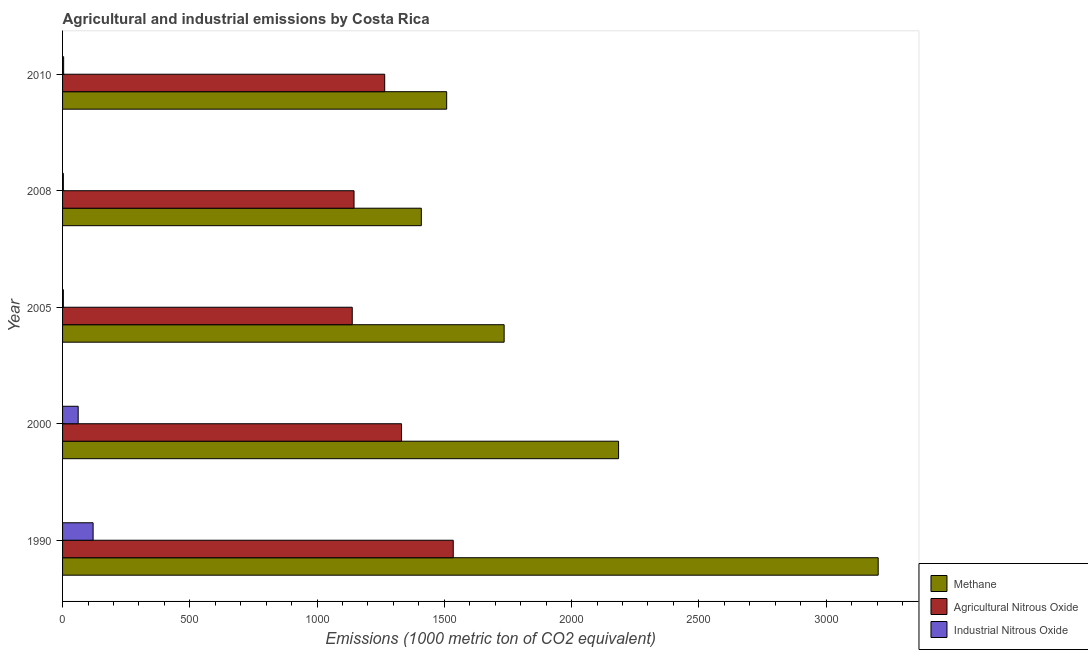How many groups of bars are there?
Give a very brief answer. 5. Are the number of bars per tick equal to the number of legend labels?
Provide a short and direct response. Yes. Are the number of bars on each tick of the Y-axis equal?
Ensure brevity in your answer.  Yes. How many bars are there on the 4th tick from the top?
Your answer should be very brief. 3. What is the amount of agricultural nitrous oxide emissions in 2008?
Your response must be concise. 1145.2. Across all years, what is the maximum amount of methane emissions?
Your answer should be very brief. 3204.6. In which year was the amount of agricultural nitrous oxide emissions maximum?
Keep it short and to the point. 1990. What is the total amount of agricultural nitrous oxide emissions in the graph?
Provide a succinct answer. 6415.9. What is the difference between the amount of methane emissions in 2005 and that in 2008?
Offer a very short reply. 325.4. What is the difference between the amount of industrial nitrous oxide emissions in 2000 and the amount of methane emissions in 2008?
Your answer should be compact. -1348.2. What is the average amount of industrial nitrous oxide emissions per year?
Provide a succinct answer. 38.36. In the year 2010, what is the difference between the amount of industrial nitrous oxide emissions and amount of methane emissions?
Your answer should be compact. -1505. In how many years, is the amount of industrial nitrous oxide emissions greater than 1400 metric ton?
Ensure brevity in your answer.  0. What is the ratio of the amount of industrial nitrous oxide emissions in 2005 to that in 2008?
Offer a very short reply. 1. Is the amount of agricultural nitrous oxide emissions in 2000 less than that in 2005?
Provide a succinct answer. No. Is the difference between the amount of industrial nitrous oxide emissions in 1990 and 2005 greater than the difference between the amount of methane emissions in 1990 and 2005?
Provide a short and direct response. No. What is the difference between the highest and the second highest amount of industrial nitrous oxide emissions?
Keep it short and to the point. 58.6. What is the difference between the highest and the lowest amount of industrial nitrous oxide emissions?
Offer a terse response. 116.9. In how many years, is the amount of industrial nitrous oxide emissions greater than the average amount of industrial nitrous oxide emissions taken over all years?
Give a very brief answer. 2. What does the 2nd bar from the top in 1990 represents?
Offer a very short reply. Agricultural Nitrous Oxide. What does the 2nd bar from the bottom in 2008 represents?
Make the answer very short. Agricultural Nitrous Oxide. How many bars are there?
Keep it short and to the point. 15. Are all the bars in the graph horizontal?
Provide a succinct answer. Yes. How many years are there in the graph?
Give a very brief answer. 5. What is the difference between two consecutive major ticks on the X-axis?
Give a very brief answer. 500. Are the values on the major ticks of X-axis written in scientific E-notation?
Provide a short and direct response. No. Does the graph contain any zero values?
Offer a terse response. No. Does the graph contain grids?
Give a very brief answer. No. Where does the legend appear in the graph?
Keep it short and to the point. Bottom right. How are the legend labels stacked?
Ensure brevity in your answer.  Vertical. What is the title of the graph?
Provide a short and direct response. Agricultural and industrial emissions by Costa Rica. Does "Ages 20-60" appear as one of the legend labels in the graph?
Provide a succinct answer. No. What is the label or title of the X-axis?
Your response must be concise. Emissions (1000 metric ton of CO2 equivalent). What is the label or title of the Y-axis?
Make the answer very short. Year. What is the Emissions (1000 metric ton of CO2 equivalent) of Methane in 1990?
Offer a terse response. 3204.6. What is the Emissions (1000 metric ton of CO2 equivalent) in Agricultural Nitrous Oxide in 1990?
Your response must be concise. 1535. What is the Emissions (1000 metric ton of CO2 equivalent) in Industrial Nitrous Oxide in 1990?
Make the answer very short. 120. What is the Emissions (1000 metric ton of CO2 equivalent) in Methane in 2000?
Offer a very short reply. 2184.6. What is the Emissions (1000 metric ton of CO2 equivalent) of Agricultural Nitrous Oxide in 2000?
Give a very brief answer. 1331.8. What is the Emissions (1000 metric ton of CO2 equivalent) of Industrial Nitrous Oxide in 2000?
Make the answer very short. 61.4. What is the Emissions (1000 metric ton of CO2 equivalent) of Methane in 2005?
Provide a succinct answer. 1735. What is the Emissions (1000 metric ton of CO2 equivalent) in Agricultural Nitrous Oxide in 2005?
Provide a short and direct response. 1138.2. What is the Emissions (1000 metric ton of CO2 equivalent) of Industrial Nitrous Oxide in 2005?
Keep it short and to the point. 3.1. What is the Emissions (1000 metric ton of CO2 equivalent) of Methane in 2008?
Ensure brevity in your answer.  1409.6. What is the Emissions (1000 metric ton of CO2 equivalent) in Agricultural Nitrous Oxide in 2008?
Provide a succinct answer. 1145.2. What is the Emissions (1000 metric ton of CO2 equivalent) of Industrial Nitrous Oxide in 2008?
Provide a succinct answer. 3.1. What is the Emissions (1000 metric ton of CO2 equivalent) of Methane in 2010?
Keep it short and to the point. 1509.2. What is the Emissions (1000 metric ton of CO2 equivalent) of Agricultural Nitrous Oxide in 2010?
Provide a succinct answer. 1265.7. Across all years, what is the maximum Emissions (1000 metric ton of CO2 equivalent) in Methane?
Ensure brevity in your answer.  3204.6. Across all years, what is the maximum Emissions (1000 metric ton of CO2 equivalent) in Agricultural Nitrous Oxide?
Give a very brief answer. 1535. Across all years, what is the maximum Emissions (1000 metric ton of CO2 equivalent) of Industrial Nitrous Oxide?
Provide a succinct answer. 120. Across all years, what is the minimum Emissions (1000 metric ton of CO2 equivalent) of Methane?
Ensure brevity in your answer.  1409.6. Across all years, what is the minimum Emissions (1000 metric ton of CO2 equivalent) of Agricultural Nitrous Oxide?
Offer a very short reply. 1138.2. Across all years, what is the minimum Emissions (1000 metric ton of CO2 equivalent) of Industrial Nitrous Oxide?
Offer a very short reply. 3.1. What is the total Emissions (1000 metric ton of CO2 equivalent) of Methane in the graph?
Make the answer very short. 1.00e+04. What is the total Emissions (1000 metric ton of CO2 equivalent) in Agricultural Nitrous Oxide in the graph?
Your answer should be very brief. 6415.9. What is the total Emissions (1000 metric ton of CO2 equivalent) in Industrial Nitrous Oxide in the graph?
Your response must be concise. 191.8. What is the difference between the Emissions (1000 metric ton of CO2 equivalent) in Methane in 1990 and that in 2000?
Offer a very short reply. 1020. What is the difference between the Emissions (1000 metric ton of CO2 equivalent) of Agricultural Nitrous Oxide in 1990 and that in 2000?
Your answer should be compact. 203.2. What is the difference between the Emissions (1000 metric ton of CO2 equivalent) of Industrial Nitrous Oxide in 1990 and that in 2000?
Your answer should be very brief. 58.6. What is the difference between the Emissions (1000 metric ton of CO2 equivalent) of Methane in 1990 and that in 2005?
Provide a succinct answer. 1469.6. What is the difference between the Emissions (1000 metric ton of CO2 equivalent) of Agricultural Nitrous Oxide in 1990 and that in 2005?
Your response must be concise. 396.8. What is the difference between the Emissions (1000 metric ton of CO2 equivalent) of Industrial Nitrous Oxide in 1990 and that in 2005?
Offer a very short reply. 116.9. What is the difference between the Emissions (1000 metric ton of CO2 equivalent) in Methane in 1990 and that in 2008?
Your answer should be compact. 1795. What is the difference between the Emissions (1000 metric ton of CO2 equivalent) in Agricultural Nitrous Oxide in 1990 and that in 2008?
Provide a short and direct response. 389.8. What is the difference between the Emissions (1000 metric ton of CO2 equivalent) in Industrial Nitrous Oxide in 1990 and that in 2008?
Provide a short and direct response. 116.9. What is the difference between the Emissions (1000 metric ton of CO2 equivalent) in Methane in 1990 and that in 2010?
Make the answer very short. 1695.4. What is the difference between the Emissions (1000 metric ton of CO2 equivalent) of Agricultural Nitrous Oxide in 1990 and that in 2010?
Ensure brevity in your answer.  269.3. What is the difference between the Emissions (1000 metric ton of CO2 equivalent) in Industrial Nitrous Oxide in 1990 and that in 2010?
Offer a terse response. 115.8. What is the difference between the Emissions (1000 metric ton of CO2 equivalent) of Methane in 2000 and that in 2005?
Give a very brief answer. 449.6. What is the difference between the Emissions (1000 metric ton of CO2 equivalent) of Agricultural Nitrous Oxide in 2000 and that in 2005?
Keep it short and to the point. 193.6. What is the difference between the Emissions (1000 metric ton of CO2 equivalent) in Industrial Nitrous Oxide in 2000 and that in 2005?
Your answer should be very brief. 58.3. What is the difference between the Emissions (1000 metric ton of CO2 equivalent) of Methane in 2000 and that in 2008?
Ensure brevity in your answer.  775. What is the difference between the Emissions (1000 metric ton of CO2 equivalent) in Agricultural Nitrous Oxide in 2000 and that in 2008?
Provide a short and direct response. 186.6. What is the difference between the Emissions (1000 metric ton of CO2 equivalent) of Industrial Nitrous Oxide in 2000 and that in 2008?
Keep it short and to the point. 58.3. What is the difference between the Emissions (1000 metric ton of CO2 equivalent) of Methane in 2000 and that in 2010?
Give a very brief answer. 675.4. What is the difference between the Emissions (1000 metric ton of CO2 equivalent) in Agricultural Nitrous Oxide in 2000 and that in 2010?
Provide a succinct answer. 66.1. What is the difference between the Emissions (1000 metric ton of CO2 equivalent) in Industrial Nitrous Oxide in 2000 and that in 2010?
Make the answer very short. 57.2. What is the difference between the Emissions (1000 metric ton of CO2 equivalent) in Methane in 2005 and that in 2008?
Your answer should be very brief. 325.4. What is the difference between the Emissions (1000 metric ton of CO2 equivalent) of Industrial Nitrous Oxide in 2005 and that in 2008?
Offer a terse response. 0. What is the difference between the Emissions (1000 metric ton of CO2 equivalent) in Methane in 2005 and that in 2010?
Offer a terse response. 225.8. What is the difference between the Emissions (1000 metric ton of CO2 equivalent) of Agricultural Nitrous Oxide in 2005 and that in 2010?
Give a very brief answer. -127.5. What is the difference between the Emissions (1000 metric ton of CO2 equivalent) of Industrial Nitrous Oxide in 2005 and that in 2010?
Your answer should be very brief. -1.1. What is the difference between the Emissions (1000 metric ton of CO2 equivalent) in Methane in 2008 and that in 2010?
Give a very brief answer. -99.6. What is the difference between the Emissions (1000 metric ton of CO2 equivalent) in Agricultural Nitrous Oxide in 2008 and that in 2010?
Your answer should be compact. -120.5. What is the difference between the Emissions (1000 metric ton of CO2 equivalent) of Methane in 1990 and the Emissions (1000 metric ton of CO2 equivalent) of Agricultural Nitrous Oxide in 2000?
Your response must be concise. 1872.8. What is the difference between the Emissions (1000 metric ton of CO2 equivalent) in Methane in 1990 and the Emissions (1000 metric ton of CO2 equivalent) in Industrial Nitrous Oxide in 2000?
Keep it short and to the point. 3143.2. What is the difference between the Emissions (1000 metric ton of CO2 equivalent) in Agricultural Nitrous Oxide in 1990 and the Emissions (1000 metric ton of CO2 equivalent) in Industrial Nitrous Oxide in 2000?
Provide a short and direct response. 1473.6. What is the difference between the Emissions (1000 metric ton of CO2 equivalent) in Methane in 1990 and the Emissions (1000 metric ton of CO2 equivalent) in Agricultural Nitrous Oxide in 2005?
Give a very brief answer. 2066.4. What is the difference between the Emissions (1000 metric ton of CO2 equivalent) of Methane in 1990 and the Emissions (1000 metric ton of CO2 equivalent) of Industrial Nitrous Oxide in 2005?
Offer a very short reply. 3201.5. What is the difference between the Emissions (1000 metric ton of CO2 equivalent) in Agricultural Nitrous Oxide in 1990 and the Emissions (1000 metric ton of CO2 equivalent) in Industrial Nitrous Oxide in 2005?
Make the answer very short. 1531.9. What is the difference between the Emissions (1000 metric ton of CO2 equivalent) in Methane in 1990 and the Emissions (1000 metric ton of CO2 equivalent) in Agricultural Nitrous Oxide in 2008?
Your response must be concise. 2059.4. What is the difference between the Emissions (1000 metric ton of CO2 equivalent) in Methane in 1990 and the Emissions (1000 metric ton of CO2 equivalent) in Industrial Nitrous Oxide in 2008?
Make the answer very short. 3201.5. What is the difference between the Emissions (1000 metric ton of CO2 equivalent) of Agricultural Nitrous Oxide in 1990 and the Emissions (1000 metric ton of CO2 equivalent) of Industrial Nitrous Oxide in 2008?
Offer a terse response. 1531.9. What is the difference between the Emissions (1000 metric ton of CO2 equivalent) in Methane in 1990 and the Emissions (1000 metric ton of CO2 equivalent) in Agricultural Nitrous Oxide in 2010?
Give a very brief answer. 1938.9. What is the difference between the Emissions (1000 metric ton of CO2 equivalent) in Methane in 1990 and the Emissions (1000 metric ton of CO2 equivalent) in Industrial Nitrous Oxide in 2010?
Your answer should be compact. 3200.4. What is the difference between the Emissions (1000 metric ton of CO2 equivalent) of Agricultural Nitrous Oxide in 1990 and the Emissions (1000 metric ton of CO2 equivalent) of Industrial Nitrous Oxide in 2010?
Provide a succinct answer. 1530.8. What is the difference between the Emissions (1000 metric ton of CO2 equivalent) of Methane in 2000 and the Emissions (1000 metric ton of CO2 equivalent) of Agricultural Nitrous Oxide in 2005?
Provide a short and direct response. 1046.4. What is the difference between the Emissions (1000 metric ton of CO2 equivalent) in Methane in 2000 and the Emissions (1000 metric ton of CO2 equivalent) in Industrial Nitrous Oxide in 2005?
Provide a short and direct response. 2181.5. What is the difference between the Emissions (1000 metric ton of CO2 equivalent) in Agricultural Nitrous Oxide in 2000 and the Emissions (1000 metric ton of CO2 equivalent) in Industrial Nitrous Oxide in 2005?
Your answer should be very brief. 1328.7. What is the difference between the Emissions (1000 metric ton of CO2 equivalent) in Methane in 2000 and the Emissions (1000 metric ton of CO2 equivalent) in Agricultural Nitrous Oxide in 2008?
Your answer should be very brief. 1039.4. What is the difference between the Emissions (1000 metric ton of CO2 equivalent) in Methane in 2000 and the Emissions (1000 metric ton of CO2 equivalent) in Industrial Nitrous Oxide in 2008?
Make the answer very short. 2181.5. What is the difference between the Emissions (1000 metric ton of CO2 equivalent) of Agricultural Nitrous Oxide in 2000 and the Emissions (1000 metric ton of CO2 equivalent) of Industrial Nitrous Oxide in 2008?
Provide a short and direct response. 1328.7. What is the difference between the Emissions (1000 metric ton of CO2 equivalent) of Methane in 2000 and the Emissions (1000 metric ton of CO2 equivalent) of Agricultural Nitrous Oxide in 2010?
Your answer should be very brief. 918.9. What is the difference between the Emissions (1000 metric ton of CO2 equivalent) of Methane in 2000 and the Emissions (1000 metric ton of CO2 equivalent) of Industrial Nitrous Oxide in 2010?
Your answer should be compact. 2180.4. What is the difference between the Emissions (1000 metric ton of CO2 equivalent) in Agricultural Nitrous Oxide in 2000 and the Emissions (1000 metric ton of CO2 equivalent) in Industrial Nitrous Oxide in 2010?
Your answer should be compact. 1327.6. What is the difference between the Emissions (1000 metric ton of CO2 equivalent) in Methane in 2005 and the Emissions (1000 metric ton of CO2 equivalent) in Agricultural Nitrous Oxide in 2008?
Make the answer very short. 589.8. What is the difference between the Emissions (1000 metric ton of CO2 equivalent) in Methane in 2005 and the Emissions (1000 metric ton of CO2 equivalent) in Industrial Nitrous Oxide in 2008?
Offer a terse response. 1731.9. What is the difference between the Emissions (1000 metric ton of CO2 equivalent) in Agricultural Nitrous Oxide in 2005 and the Emissions (1000 metric ton of CO2 equivalent) in Industrial Nitrous Oxide in 2008?
Provide a succinct answer. 1135.1. What is the difference between the Emissions (1000 metric ton of CO2 equivalent) of Methane in 2005 and the Emissions (1000 metric ton of CO2 equivalent) of Agricultural Nitrous Oxide in 2010?
Provide a short and direct response. 469.3. What is the difference between the Emissions (1000 metric ton of CO2 equivalent) in Methane in 2005 and the Emissions (1000 metric ton of CO2 equivalent) in Industrial Nitrous Oxide in 2010?
Give a very brief answer. 1730.8. What is the difference between the Emissions (1000 metric ton of CO2 equivalent) of Agricultural Nitrous Oxide in 2005 and the Emissions (1000 metric ton of CO2 equivalent) of Industrial Nitrous Oxide in 2010?
Provide a short and direct response. 1134. What is the difference between the Emissions (1000 metric ton of CO2 equivalent) of Methane in 2008 and the Emissions (1000 metric ton of CO2 equivalent) of Agricultural Nitrous Oxide in 2010?
Your answer should be compact. 143.9. What is the difference between the Emissions (1000 metric ton of CO2 equivalent) of Methane in 2008 and the Emissions (1000 metric ton of CO2 equivalent) of Industrial Nitrous Oxide in 2010?
Ensure brevity in your answer.  1405.4. What is the difference between the Emissions (1000 metric ton of CO2 equivalent) of Agricultural Nitrous Oxide in 2008 and the Emissions (1000 metric ton of CO2 equivalent) of Industrial Nitrous Oxide in 2010?
Your answer should be compact. 1141. What is the average Emissions (1000 metric ton of CO2 equivalent) in Methane per year?
Provide a short and direct response. 2008.6. What is the average Emissions (1000 metric ton of CO2 equivalent) of Agricultural Nitrous Oxide per year?
Your response must be concise. 1283.18. What is the average Emissions (1000 metric ton of CO2 equivalent) in Industrial Nitrous Oxide per year?
Your answer should be compact. 38.36. In the year 1990, what is the difference between the Emissions (1000 metric ton of CO2 equivalent) in Methane and Emissions (1000 metric ton of CO2 equivalent) in Agricultural Nitrous Oxide?
Provide a succinct answer. 1669.6. In the year 1990, what is the difference between the Emissions (1000 metric ton of CO2 equivalent) of Methane and Emissions (1000 metric ton of CO2 equivalent) of Industrial Nitrous Oxide?
Make the answer very short. 3084.6. In the year 1990, what is the difference between the Emissions (1000 metric ton of CO2 equivalent) of Agricultural Nitrous Oxide and Emissions (1000 metric ton of CO2 equivalent) of Industrial Nitrous Oxide?
Your response must be concise. 1415. In the year 2000, what is the difference between the Emissions (1000 metric ton of CO2 equivalent) in Methane and Emissions (1000 metric ton of CO2 equivalent) in Agricultural Nitrous Oxide?
Ensure brevity in your answer.  852.8. In the year 2000, what is the difference between the Emissions (1000 metric ton of CO2 equivalent) in Methane and Emissions (1000 metric ton of CO2 equivalent) in Industrial Nitrous Oxide?
Provide a short and direct response. 2123.2. In the year 2000, what is the difference between the Emissions (1000 metric ton of CO2 equivalent) of Agricultural Nitrous Oxide and Emissions (1000 metric ton of CO2 equivalent) of Industrial Nitrous Oxide?
Provide a succinct answer. 1270.4. In the year 2005, what is the difference between the Emissions (1000 metric ton of CO2 equivalent) in Methane and Emissions (1000 metric ton of CO2 equivalent) in Agricultural Nitrous Oxide?
Provide a succinct answer. 596.8. In the year 2005, what is the difference between the Emissions (1000 metric ton of CO2 equivalent) of Methane and Emissions (1000 metric ton of CO2 equivalent) of Industrial Nitrous Oxide?
Your answer should be very brief. 1731.9. In the year 2005, what is the difference between the Emissions (1000 metric ton of CO2 equivalent) of Agricultural Nitrous Oxide and Emissions (1000 metric ton of CO2 equivalent) of Industrial Nitrous Oxide?
Ensure brevity in your answer.  1135.1. In the year 2008, what is the difference between the Emissions (1000 metric ton of CO2 equivalent) in Methane and Emissions (1000 metric ton of CO2 equivalent) in Agricultural Nitrous Oxide?
Make the answer very short. 264.4. In the year 2008, what is the difference between the Emissions (1000 metric ton of CO2 equivalent) in Methane and Emissions (1000 metric ton of CO2 equivalent) in Industrial Nitrous Oxide?
Your answer should be compact. 1406.5. In the year 2008, what is the difference between the Emissions (1000 metric ton of CO2 equivalent) in Agricultural Nitrous Oxide and Emissions (1000 metric ton of CO2 equivalent) in Industrial Nitrous Oxide?
Your answer should be compact. 1142.1. In the year 2010, what is the difference between the Emissions (1000 metric ton of CO2 equivalent) of Methane and Emissions (1000 metric ton of CO2 equivalent) of Agricultural Nitrous Oxide?
Provide a succinct answer. 243.5. In the year 2010, what is the difference between the Emissions (1000 metric ton of CO2 equivalent) of Methane and Emissions (1000 metric ton of CO2 equivalent) of Industrial Nitrous Oxide?
Make the answer very short. 1505. In the year 2010, what is the difference between the Emissions (1000 metric ton of CO2 equivalent) of Agricultural Nitrous Oxide and Emissions (1000 metric ton of CO2 equivalent) of Industrial Nitrous Oxide?
Ensure brevity in your answer.  1261.5. What is the ratio of the Emissions (1000 metric ton of CO2 equivalent) of Methane in 1990 to that in 2000?
Your answer should be very brief. 1.47. What is the ratio of the Emissions (1000 metric ton of CO2 equivalent) in Agricultural Nitrous Oxide in 1990 to that in 2000?
Provide a succinct answer. 1.15. What is the ratio of the Emissions (1000 metric ton of CO2 equivalent) of Industrial Nitrous Oxide in 1990 to that in 2000?
Your answer should be very brief. 1.95. What is the ratio of the Emissions (1000 metric ton of CO2 equivalent) of Methane in 1990 to that in 2005?
Ensure brevity in your answer.  1.85. What is the ratio of the Emissions (1000 metric ton of CO2 equivalent) of Agricultural Nitrous Oxide in 1990 to that in 2005?
Offer a very short reply. 1.35. What is the ratio of the Emissions (1000 metric ton of CO2 equivalent) in Industrial Nitrous Oxide in 1990 to that in 2005?
Provide a short and direct response. 38.71. What is the ratio of the Emissions (1000 metric ton of CO2 equivalent) of Methane in 1990 to that in 2008?
Your answer should be compact. 2.27. What is the ratio of the Emissions (1000 metric ton of CO2 equivalent) in Agricultural Nitrous Oxide in 1990 to that in 2008?
Keep it short and to the point. 1.34. What is the ratio of the Emissions (1000 metric ton of CO2 equivalent) in Industrial Nitrous Oxide in 1990 to that in 2008?
Provide a succinct answer. 38.71. What is the ratio of the Emissions (1000 metric ton of CO2 equivalent) of Methane in 1990 to that in 2010?
Your answer should be compact. 2.12. What is the ratio of the Emissions (1000 metric ton of CO2 equivalent) in Agricultural Nitrous Oxide in 1990 to that in 2010?
Your answer should be compact. 1.21. What is the ratio of the Emissions (1000 metric ton of CO2 equivalent) in Industrial Nitrous Oxide in 1990 to that in 2010?
Keep it short and to the point. 28.57. What is the ratio of the Emissions (1000 metric ton of CO2 equivalent) of Methane in 2000 to that in 2005?
Keep it short and to the point. 1.26. What is the ratio of the Emissions (1000 metric ton of CO2 equivalent) of Agricultural Nitrous Oxide in 2000 to that in 2005?
Provide a succinct answer. 1.17. What is the ratio of the Emissions (1000 metric ton of CO2 equivalent) in Industrial Nitrous Oxide in 2000 to that in 2005?
Your answer should be very brief. 19.81. What is the ratio of the Emissions (1000 metric ton of CO2 equivalent) in Methane in 2000 to that in 2008?
Offer a very short reply. 1.55. What is the ratio of the Emissions (1000 metric ton of CO2 equivalent) of Agricultural Nitrous Oxide in 2000 to that in 2008?
Make the answer very short. 1.16. What is the ratio of the Emissions (1000 metric ton of CO2 equivalent) in Industrial Nitrous Oxide in 2000 to that in 2008?
Give a very brief answer. 19.81. What is the ratio of the Emissions (1000 metric ton of CO2 equivalent) in Methane in 2000 to that in 2010?
Offer a terse response. 1.45. What is the ratio of the Emissions (1000 metric ton of CO2 equivalent) in Agricultural Nitrous Oxide in 2000 to that in 2010?
Make the answer very short. 1.05. What is the ratio of the Emissions (1000 metric ton of CO2 equivalent) in Industrial Nitrous Oxide in 2000 to that in 2010?
Give a very brief answer. 14.62. What is the ratio of the Emissions (1000 metric ton of CO2 equivalent) of Methane in 2005 to that in 2008?
Your answer should be very brief. 1.23. What is the ratio of the Emissions (1000 metric ton of CO2 equivalent) of Agricultural Nitrous Oxide in 2005 to that in 2008?
Your answer should be very brief. 0.99. What is the ratio of the Emissions (1000 metric ton of CO2 equivalent) of Industrial Nitrous Oxide in 2005 to that in 2008?
Offer a very short reply. 1. What is the ratio of the Emissions (1000 metric ton of CO2 equivalent) in Methane in 2005 to that in 2010?
Keep it short and to the point. 1.15. What is the ratio of the Emissions (1000 metric ton of CO2 equivalent) in Agricultural Nitrous Oxide in 2005 to that in 2010?
Make the answer very short. 0.9. What is the ratio of the Emissions (1000 metric ton of CO2 equivalent) of Industrial Nitrous Oxide in 2005 to that in 2010?
Make the answer very short. 0.74. What is the ratio of the Emissions (1000 metric ton of CO2 equivalent) of Methane in 2008 to that in 2010?
Your answer should be very brief. 0.93. What is the ratio of the Emissions (1000 metric ton of CO2 equivalent) of Agricultural Nitrous Oxide in 2008 to that in 2010?
Ensure brevity in your answer.  0.9. What is the ratio of the Emissions (1000 metric ton of CO2 equivalent) of Industrial Nitrous Oxide in 2008 to that in 2010?
Ensure brevity in your answer.  0.74. What is the difference between the highest and the second highest Emissions (1000 metric ton of CO2 equivalent) in Methane?
Offer a terse response. 1020. What is the difference between the highest and the second highest Emissions (1000 metric ton of CO2 equivalent) of Agricultural Nitrous Oxide?
Keep it short and to the point. 203.2. What is the difference between the highest and the second highest Emissions (1000 metric ton of CO2 equivalent) in Industrial Nitrous Oxide?
Keep it short and to the point. 58.6. What is the difference between the highest and the lowest Emissions (1000 metric ton of CO2 equivalent) of Methane?
Your response must be concise. 1795. What is the difference between the highest and the lowest Emissions (1000 metric ton of CO2 equivalent) in Agricultural Nitrous Oxide?
Keep it short and to the point. 396.8. What is the difference between the highest and the lowest Emissions (1000 metric ton of CO2 equivalent) in Industrial Nitrous Oxide?
Offer a very short reply. 116.9. 